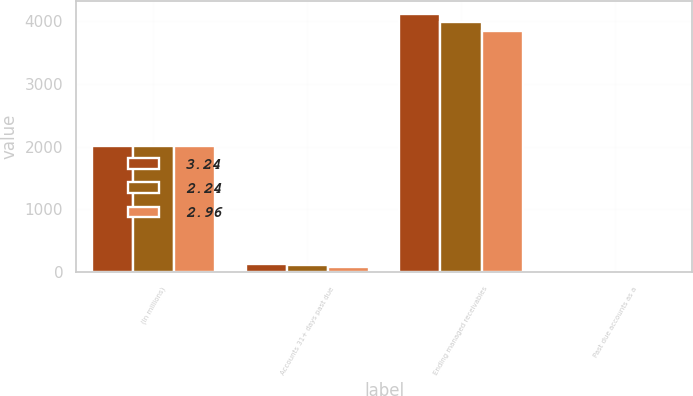<chart> <loc_0><loc_0><loc_500><loc_500><stacked_bar_chart><ecel><fcel>(In millions)<fcel>Accounts 31+ days past due<fcel>Ending managed receivables<fcel>Past due accounts as a<nl><fcel>3.24<fcel>2010<fcel>133.2<fcel>4112.7<fcel>3.24<nl><fcel>2.24<fcel>2009<fcel>118.1<fcel>3986.7<fcel>2.96<nl><fcel>2.96<fcel>2008<fcel>86.1<fcel>3838.5<fcel>2.24<nl></chart> 